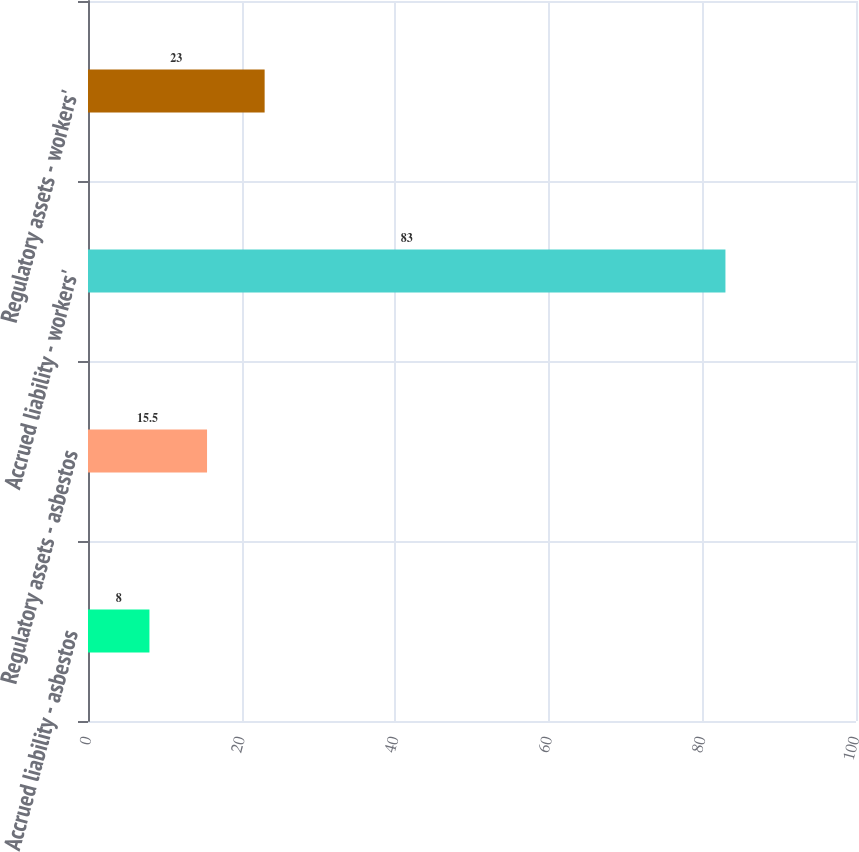Convert chart. <chart><loc_0><loc_0><loc_500><loc_500><bar_chart><fcel>Accrued liability - asbestos<fcel>Regulatory assets - asbestos<fcel>Accrued liability - workers'<fcel>Regulatory assets - workers'<nl><fcel>8<fcel>15.5<fcel>83<fcel>23<nl></chart> 